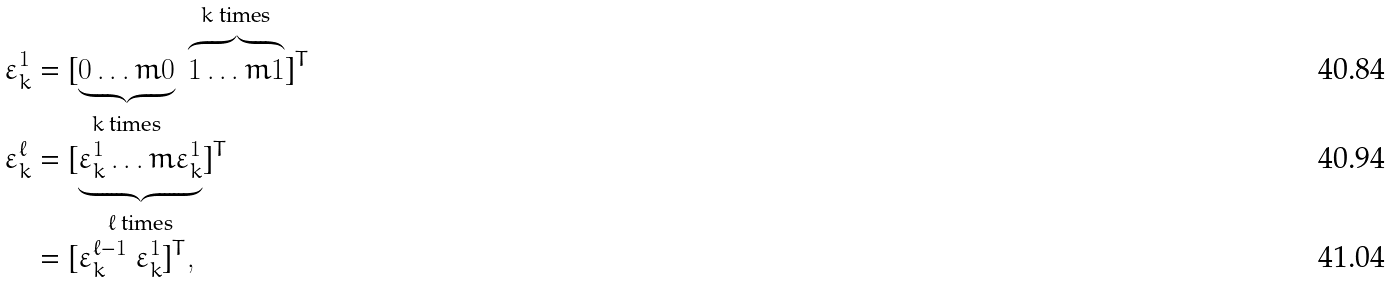<formula> <loc_0><loc_0><loc_500><loc_500>\varepsilon _ { k } ^ { 1 } & = [ \underbrace { 0 \dots m 0 } _ { \text {$k$   times} } \ \overbrace { 1 \dots m 1 } ^ { \text {$k$ times} } ] ^ { T } \\ \varepsilon _ { k } ^ { \ell } & = [ \underbrace { \varepsilon _ { k } ^ { 1 } \dots m \varepsilon _ { k } ^ { 1 } } _ { \text {$\ell$   times} } ] ^ { T } \\ & = [ \varepsilon _ { k } ^ { \ell - 1 } \ \varepsilon _ { k } ^ { 1 } ] ^ { T } ,</formula> 